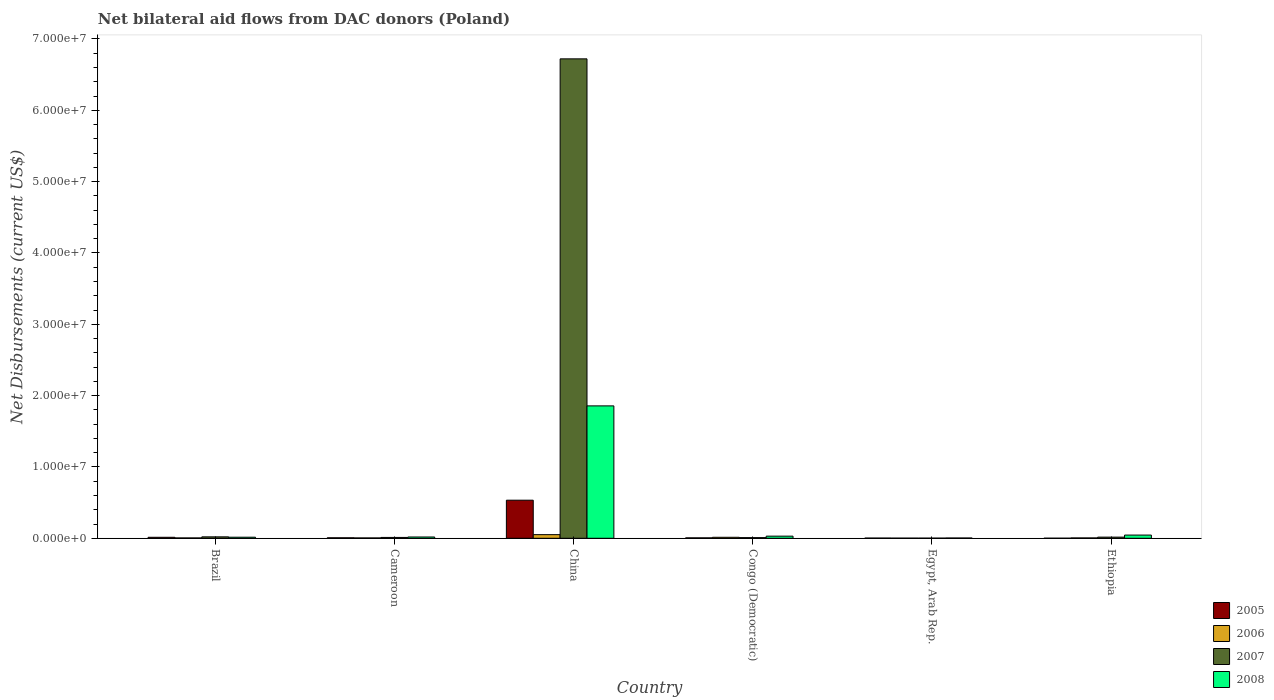Are the number of bars on each tick of the X-axis equal?
Make the answer very short. Yes. How many bars are there on the 6th tick from the left?
Your answer should be very brief. 4. What is the label of the 6th group of bars from the left?
Keep it short and to the point. Ethiopia. In how many cases, is the number of bars for a given country not equal to the number of legend labels?
Make the answer very short. 0. What is the net bilateral aid flows in 2008 in Egypt, Arab Rep.?
Ensure brevity in your answer.  4.00e+04. Across all countries, what is the maximum net bilateral aid flows in 2005?
Make the answer very short. 5.34e+06. In which country was the net bilateral aid flows in 2008 minimum?
Ensure brevity in your answer.  Egypt, Arab Rep. What is the total net bilateral aid flows in 2005 in the graph?
Offer a terse response. 5.65e+06. What is the difference between the net bilateral aid flows in 2005 in Cameroon and that in Ethiopia?
Give a very brief answer. 6.00e+04. What is the average net bilateral aid flows in 2007 per country?
Ensure brevity in your answer.  1.13e+07. What is the difference between the net bilateral aid flows of/in 2008 and net bilateral aid flows of/in 2005 in Cameroon?
Give a very brief answer. 1.10e+05. In how many countries, is the net bilateral aid flows in 2008 greater than 32000000 US$?
Make the answer very short. 0. What is the ratio of the net bilateral aid flows in 2008 in Cameroon to that in China?
Keep it short and to the point. 0.01. Is the net bilateral aid flows in 2008 in Cameroon less than that in Congo (Democratic)?
Keep it short and to the point. Yes. What is the difference between the highest and the second highest net bilateral aid flows in 2008?
Keep it short and to the point. 1.83e+07. What is the difference between the highest and the lowest net bilateral aid flows in 2008?
Your response must be concise. 1.85e+07. In how many countries, is the net bilateral aid flows in 2005 greater than the average net bilateral aid flows in 2005 taken over all countries?
Your answer should be very brief. 1. Is it the case that in every country, the sum of the net bilateral aid flows in 2007 and net bilateral aid flows in 2006 is greater than the sum of net bilateral aid flows in 2008 and net bilateral aid flows in 2005?
Keep it short and to the point. No. Is it the case that in every country, the sum of the net bilateral aid flows in 2007 and net bilateral aid flows in 2008 is greater than the net bilateral aid flows in 2005?
Make the answer very short. Yes. How many bars are there?
Keep it short and to the point. 24. Are all the bars in the graph horizontal?
Your answer should be very brief. No. How many countries are there in the graph?
Provide a succinct answer. 6. What is the difference between two consecutive major ticks on the Y-axis?
Make the answer very short. 1.00e+07. Are the values on the major ticks of Y-axis written in scientific E-notation?
Your response must be concise. Yes. Does the graph contain grids?
Make the answer very short. No. Where does the legend appear in the graph?
Ensure brevity in your answer.  Bottom right. How are the legend labels stacked?
Offer a very short reply. Vertical. What is the title of the graph?
Make the answer very short. Net bilateral aid flows from DAC donors (Poland). Does "1967" appear as one of the legend labels in the graph?
Provide a short and direct response. No. What is the label or title of the Y-axis?
Keep it short and to the point. Net Disbursements (current US$). What is the Net Disbursements (current US$) in 2006 in Brazil?
Offer a terse response. 5.00e+04. What is the Net Disbursements (current US$) in 2007 in Brazil?
Offer a very short reply. 2.00e+05. What is the Net Disbursements (current US$) in 2005 in Cameroon?
Your answer should be compact. 7.00e+04. What is the Net Disbursements (current US$) in 2008 in Cameroon?
Provide a succinct answer. 1.80e+05. What is the Net Disbursements (current US$) in 2005 in China?
Ensure brevity in your answer.  5.34e+06. What is the Net Disbursements (current US$) in 2006 in China?
Keep it short and to the point. 5.10e+05. What is the Net Disbursements (current US$) in 2007 in China?
Keep it short and to the point. 6.72e+07. What is the Net Disbursements (current US$) of 2008 in China?
Provide a short and direct response. 1.86e+07. What is the Net Disbursements (current US$) of 2005 in Congo (Democratic)?
Ensure brevity in your answer.  6.00e+04. What is the Net Disbursements (current US$) in 2006 in Congo (Democratic)?
Your answer should be compact. 1.40e+05. What is the Net Disbursements (current US$) in 2007 in Congo (Democratic)?
Offer a very short reply. 9.00e+04. What is the Net Disbursements (current US$) in 2005 in Egypt, Arab Rep.?
Offer a very short reply. 3.00e+04. What is the Net Disbursements (current US$) of 2006 in Egypt, Arab Rep.?
Ensure brevity in your answer.  2.00e+04. What is the Net Disbursements (current US$) in 2008 in Egypt, Arab Rep.?
Provide a succinct answer. 4.00e+04. What is the Net Disbursements (current US$) of 2005 in Ethiopia?
Your answer should be compact. 10000. What is the Net Disbursements (current US$) of 2007 in Ethiopia?
Ensure brevity in your answer.  1.60e+05. Across all countries, what is the maximum Net Disbursements (current US$) in 2005?
Offer a very short reply. 5.34e+06. Across all countries, what is the maximum Net Disbursements (current US$) in 2006?
Provide a succinct answer. 5.10e+05. Across all countries, what is the maximum Net Disbursements (current US$) in 2007?
Keep it short and to the point. 6.72e+07. Across all countries, what is the maximum Net Disbursements (current US$) of 2008?
Provide a succinct answer. 1.86e+07. Across all countries, what is the minimum Net Disbursements (current US$) of 2005?
Offer a terse response. 10000. Across all countries, what is the minimum Net Disbursements (current US$) of 2006?
Make the answer very short. 2.00e+04. Across all countries, what is the minimum Net Disbursements (current US$) in 2007?
Your response must be concise. 2.00e+04. What is the total Net Disbursements (current US$) of 2005 in the graph?
Make the answer very short. 5.65e+06. What is the total Net Disbursements (current US$) in 2006 in the graph?
Make the answer very short. 8.20e+05. What is the total Net Disbursements (current US$) in 2007 in the graph?
Provide a succinct answer. 6.78e+07. What is the total Net Disbursements (current US$) of 2008 in the graph?
Make the answer very short. 1.97e+07. What is the difference between the Net Disbursements (current US$) of 2005 in Brazil and that in Cameroon?
Your answer should be compact. 7.00e+04. What is the difference between the Net Disbursements (current US$) of 2005 in Brazil and that in China?
Make the answer very short. -5.20e+06. What is the difference between the Net Disbursements (current US$) of 2006 in Brazil and that in China?
Keep it short and to the point. -4.60e+05. What is the difference between the Net Disbursements (current US$) in 2007 in Brazil and that in China?
Give a very brief answer. -6.70e+07. What is the difference between the Net Disbursements (current US$) of 2008 in Brazil and that in China?
Give a very brief answer. -1.84e+07. What is the difference between the Net Disbursements (current US$) of 2006 in Brazil and that in Congo (Democratic)?
Offer a very short reply. -9.00e+04. What is the difference between the Net Disbursements (current US$) in 2005 in Brazil and that in Egypt, Arab Rep.?
Offer a terse response. 1.10e+05. What is the difference between the Net Disbursements (current US$) in 2008 in Brazil and that in Egypt, Arab Rep.?
Keep it short and to the point. 1.10e+05. What is the difference between the Net Disbursements (current US$) in 2005 in Brazil and that in Ethiopia?
Offer a terse response. 1.30e+05. What is the difference between the Net Disbursements (current US$) in 2006 in Brazil and that in Ethiopia?
Your response must be concise. 0. What is the difference between the Net Disbursements (current US$) of 2007 in Brazil and that in Ethiopia?
Offer a terse response. 4.00e+04. What is the difference between the Net Disbursements (current US$) in 2005 in Cameroon and that in China?
Give a very brief answer. -5.27e+06. What is the difference between the Net Disbursements (current US$) of 2006 in Cameroon and that in China?
Your response must be concise. -4.60e+05. What is the difference between the Net Disbursements (current US$) of 2007 in Cameroon and that in China?
Offer a very short reply. -6.71e+07. What is the difference between the Net Disbursements (current US$) of 2008 in Cameroon and that in China?
Keep it short and to the point. -1.84e+07. What is the difference between the Net Disbursements (current US$) of 2006 in Cameroon and that in Egypt, Arab Rep.?
Your answer should be very brief. 3.00e+04. What is the difference between the Net Disbursements (current US$) of 2006 in Cameroon and that in Ethiopia?
Your answer should be very brief. 0. What is the difference between the Net Disbursements (current US$) in 2005 in China and that in Congo (Democratic)?
Make the answer very short. 5.28e+06. What is the difference between the Net Disbursements (current US$) in 2006 in China and that in Congo (Democratic)?
Offer a very short reply. 3.70e+05. What is the difference between the Net Disbursements (current US$) of 2007 in China and that in Congo (Democratic)?
Offer a very short reply. 6.71e+07. What is the difference between the Net Disbursements (current US$) in 2008 in China and that in Congo (Democratic)?
Offer a very short reply. 1.83e+07. What is the difference between the Net Disbursements (current US$) of 2005 in China and that in Egypt, Arab Rep.?
Your answer should be compact. 5.31e+06. What is the difference between the Net Disbursements (current US$) of 2007 in China and that in Egypt, Arab Rep.?
Provide a short and direct response. 6.72e+07. What is the difference between the Net Disbursements (current US$) in 2008 in China and that in Egypt, Arab Rep.?
Your answer should be very brief. 1.85e+07. What is the difference between the Net Disbursements (current US$) of 2005 in China and that in Ethiopia?
Offer a very short reply. 5.33e+06. What is the difference between the Net Disbursements (current US$) of 2006 in China and that in Ethiopia?
Provide a succinct answer. 4.60e+05. What is the difference between the Net Disbursements (current US$) in 2007 in China and that in Ethiopia?
Offer a very short reply. 6.70e+07. What is the difference between the Net Disbursements (current US$) of 2008 in China and that in Ethiopia?
Keep it short and to the point. 1.81e+07. What is the difference between the Net Disbursements (current US$) of 2007 in Congo (Democratic) and that in Egypt, Arab Rep.?
Offer a terse response. 7.00e+04. What is the difference between the Net Disbursements (current US$) in 2005 in Congo (Democratic) and that in Ethiopia?
Keep it short and to the point. 5.00e+04. What is the difference between the Net Disbursements (current US$) in 2006 in Congo (Democratic) and that in Ethiopia?
Make the answer very short. 9.00e+04. What is the difference between the Net Disbursements (current US$) of 2007 in Egypt, Arab Rep. and that in Ethiopia?
Make the answer very short. -1.40e+05. What is the difference between the Net Disbursements (current US$) in 2008 in Egypt, Arab Rep. and that in Ethiopia?
Keep it short and to the point. -4.10e+05. What is the difference between the Net Disbursements (current US$) of 2005 in Brazil and the Net Disbursements (current US$) of 2006 in Cameroon?
Provide a short and direct response. 9.00e+04. What is the difference between the Net Disbursements (current US$) of 2005 in Brazil and the Net Disbursements (current US$) of 2007 in Cameroon?
Provide a short and direct response. 2.00e+04. What is the difference between the Net Disbursements (current US$) of 2005 in Brazil and the Net Disbursements (current US$) of 2008 in Cameroon?
Provide a succinct answer. -4.00e+04. What is the difference between the Net Disbursements (current US$) of 2005 in Brazil and the Net Disbursements (current US$) of 2006 in China?
Provide a short and direct response. -3.70e+05. What is the difference between the Net Disbursements (current US$) in 2005 in Brazil and the Net Disbursements (current US$) in 2007 in China?
Keep it short and to the point. -6.71e+07. What is the difference between the Net Disbursements (current US$) in 2005 in Brazil and the Net Disbursements (current US$) in 2008 in China?
Provide a short and direct response. -1.84e+07. What is the difference between the Net Disbursements (current US$) in 2006 in Brazil and the Net Disbursements (current US$) in 2007 in China?
Provide a succinct answer. -6.72e+07. What is the difference between the Net Disbursements (current US$) in 2006 in Brazil and the Net Disbursements (current US$) in 2008 in China?
Your answer should be very brief. -1.85e+07. What is the difference between the Net Disbursements (current US$) of 2007 in Brazil and the Net Disbursements (current US$) of 2008 in China?
Your answer should be compact. -1.84e+07. What is the difference between the Net Disbursements (current US$) in 2005 in Brazil and the Net Disbursements (current US$) in 2008 in Congo (Democratic)?
Give a very brief answer. -1.60e+05. What is the difference between the Net Disbursements (current US$) of 2006 in Brazil and the Net Disbursements (current US$) of 2007 in Congo (Democratic)?
Your answer should be compact. -4.00e+04. What is the difference between the Net Disbursements (current US$) of 2006 in Brazil and the Net Disbursements (current US$) of 2008 in Congo (Democratic)?
Provide a short and direct response. -2.50e+05. What is the difference between the Net Disbursements (current US$) in 2006 in Brazil and the Net Disbursements (current US$) in 2008 in Egypt, Arab Rep.?
Provide a succinct answer. 10000. What is the difference between the Net Disbursements (current US$) in 2007 in Brazil and the Net Disbursements (current US$) in 2008 in Egypt, Arab Rep.?
Make the answer very short. 1.60e+05. What is the difference between the Net Disbursements (current US$) in 2005 in Brazil and the Net Disbursements (current US$) in 2008 in Ethiopia?
Make the answer very short. -3.10e+05. What is the difference between the Net Disbursements (current US$) of 2006 in Brazil and the Net Disbursements (current US$) of 2007 in Ethiopia?
Offer a terse response. -1.10e+05. What is the difference between the Net Disbursements (current US$) in 2006 in Brazil and the Net Disbursements (current US$) in 2008 in Ethiopia?
Give a very brief answer. -4.00e+05. What is the difference between the Net Disbursements (current US$) of 2007 in Brazil and the Net Disbursements (current US$) of 2008 in Ethiopia?
Keep it short and to the point. -2.50e+05. What is the difference between the Net Disbursements (current US$) of 2005 in Cameroon and the Net Disbursements (current US$) of 2006 in China?
Keep it short and to the point. -4.40e+05. What is the difference between the Net Disbursements (current US$) of 2005 in Cameroon and the Net Disbursements (current US$) of 2007 in China?
Ensure brevity in your answer.  -6.71e+07. What is the difference between the Net Disbursements (current US$) in 2005 in Cameroon and the Net Disbursements (current US$) in 2008 in China?
Give a very brief answer. -1.85e+07. What is the difference between the Net Disbursements (current US$) of 2006 in Cameroon and the Net Disbursements (current US$) of 2007 in China?
Make the answer very short. -6.72e+07. What is the difference between the Net Disbursements (current US$) of 2006 in Cameroon and the Net Disbursements (current US$) of 2008 in China?
Offer a very short reply. -1.85e+07. What is the difference between the Net Disbursements (current US$) in 2007 in Cameroon and the Net Disbursements (current US$) in 2008 in China?
Provide a short and direct response. -1.84e+07. What is the difference between the Net Disbursements (current US$) in 2005 in Cameroon and the Net Disbursements (current US$) in 2006 in Congo (Democratic)?
Your answer should be very brief. -7.00e+04. What is the difference between the Net Disbursements (current US$) in 2006 in Cameroon and the Net Disbursements (current US$) in 2007 in Congo (Democratic)?
Make the answer very short. -4.00e+04. What is the difference between the Net Disbursements (current US$) in 2006 in Cameroon and the Net Disbursements (current US$) in 2008 in Congo (Democratic)?
Provide a succinct answer. -2.50e+05. What is the difference between the Net Disbursements (current US$) in 2005 in Cameroon and the Net Disbursements (current US$) in 2007 in Egypt, Arab Rep.?
Your answer should be very brief. 5.00e+04. What is the difference between the Net Disbursements (current US$) of 2005 in Cameroon and the Net Disbursements (current US$) of 2008 in Egypt, Arab Rep.?
Your answer should be very brief. 3.00e+04. What is the difference between the Net Disbursements (current US$) of 2006 in Cameroon and the Net Disbursements (current US$) of 2008 in Egypt, Arab Rep.?
Your answer should be compact. 10000. What is the difference between the Net Disbursements (current US$) in 2005 in Cameroon and the Net Disbursements (current US$) in 2006 in Ethiopia?
Your answer should be very brief. 2.00e+04. What is the difference between the Net Disbursements (current US$) of 2005 in Cameroon and the Net Disbursements (current US$) of 2008 in Ethiopia?
Ensure brevity in your answer.  -3.80e+05. What is the difference between the Net Disbursements (current US$) of 2006 in Cameroon and the Net Disbursements (current US$) of 2007 in Ethiopia?
Your answer should be compact. -1.10e+05. What is the difference between the Net Disbursements (current US$) in 2006 in Cameroon and the Net Disbursements (current US$) in 2008 in Ethiopia?
Keep it short and to the point. -4.00e+05. What is the difference between the Net Disbursements (current US$) of 2007 in Cameroon and the Net Disbursements (current US$) of 2008 in Ethiopia?
Ensure brevity in your answer.  -3.30e+05. What is the difference between the Net Disbursements (current US$) in 2005 in China and the Net Disbursements (current US$) in 2006 in Congo (Democratic)?
Provide a short and direct response. 5.20e+06. What is the difference between the Net Disbursements (current US$) of 2005 in China and the Net Disbursements (current US$) of 2007 in Congo (Democratic)?
Make the answer very short. 5.25e+06. What is the difference between the Net Disbursements (current US$) of 2005 in China and the Net Disbursements (current US$) of 2008 in Congo (Democratic)?
Your response must be concise. 5.04e+06. What is the difference between the Net Disbursements (current US$) of 2006 in China and the Net Disbursements (current US$) of 2007 in Congo (Democratic)?
Ensure brevity in your answer.  4.20e+05. What is the difference between the Net Disbursements (current US$) in 2007 in China and the Net Disbursements (current US$) in 2008 in Congo (Democratic)?
Give a very brief answer. 6.69e+07. What is the difference between the Net Disbursements (current US$) of 2005 in China and the Net Disbursements (current US$) of 2006 in Egypt, Arab Rep.?
Offer a terse response. 5.32e+06. What is the difference between the Net Disbursements (current US$) in 2005 in China and the Net Disbursements (current US$) in 2007 in Egypt, Arab Rep.?
Make the answer very short. 5.32e+06. What is the difference between the Net Disbursements (current US$) in 2005 in China and the Net Disbursements (current US$) in 2008 in Egypt, Arab Rep.?
Your answer should be very brief. 5.30e+06. What is the difference between the Net Disbursements (current US$) of 2006 in China and the Net Disbursements (current US$) of 2007 in Egypt, Arab Rep.?
Make the answer very short. 4.90e+05. What is the difference between the Net Disbursements (current US$) of 2006 in China and the Net Disbursements (current US$) of 2008 in Egypt, Arab Rep.?
Provide a short and direct response. 4.70e+05. What is the difference between the Net Disbursements (current US$) of 2007 in China and the Net Disbursements (current US$) of 2008 in Egypt, Arab Rep.?
Your answer should be compact. 6.72e+07. What is the difference between the Net Disbursements (current US$) in 2005 in China and the Net Disbursements (current US$) in 2006 in Ethiopia?
Provide a short and direct response. 5.29e+06. What is the difference between the Net Disbursements (current US$) in 2005 in China and the Net Disbursements (current US$) in 2007 in Ethiopia?
Your answer should be very brief. 5.18e+06. What is the difference between the Net Disbursements (current US$) of 2005 in China and the Net Disbursements (current US$) of 2008 in Ethiopia?
Provide a short and direct response. 4.89e+06. What is the difference between the Net Disbursements (current US$) in 2006 in China and the Net Disbursements (current US$) in 2008 in Ethiopia?
Make the answer very short. 6.00e+04. What is the difference between the Net Disbursements (current US$) of 2007 in China and the Net Disbursements (current US$) of 2008 in Ethiopia?
Give a very brief answer. 6.68e+07. What is the difference between the Net Disbursements (current US$) in 2005 in Congo (Democratic) and the Net Disbursements (current US$) in 2008 in Egypt, Arab Rep.?
Keep it short and to the point. 2.00e+04. What is the difference between the Net Disbursements (current US$) in 2006 in Congo (Democratic) and the Net Disbursements (current US$) in 2007 in Egypt, Arab Rep.?
Your response must be concise. 1.20e+05. What is the difference between the Net Disbursements (current US$) in 2006 in Congo (Democratic) and the Net Disbursements (current US$) in 2008 in Egypt, Arab Rep.?
Give a very brief answer. 1.00e+05. What is the difference between the Net Disbursements (current US$) of 2005 in Congo (Democratic) and the Net Disbursements (current US$) of 2006 in Ethiopia?
Your response must be concise. 10000. What is the difference between the Net Disbursements (current US$) in 2005 in Congo (Democratic) and the Net Disbursements (current US$) in 2008 in Ethiopia?
Offer a very short reply. -3.90e+05. What is the difference between the Net Disbursements (current US$) in 2006 in Congo (Democratic) and the Net Disbursements (current US$) in 2008 in Ethiopia?
Make the answer very short. -3.10e+05. What is the difference between the Net Disbursements (current US$) of 2007 in Congo (Democratic) and the Net Disbursements (current US$) of 2008 in Ethiopia?
Provide a short and direct response. -3.60e+05. What is the difference between the Net Disbursements (current US$) in 2005 in Egypt, Arab Rep. and the Net Disbursements (current US$) in 2007 in Ethiopia?
Your answer should be very brief. -1.30e+05. What is the difference between the Net Disbursements (current US$) in 2005 in Egypt, Arab Rep. and the Net Disbursements (current US$) in 2008 in Ethiopia?
Provide a short and direct response. -4.20e+05. What is the difference between the Net Disbursements (current US$) in 2006 in Egypt, Arab Rep. and the Net Disbursements (current US$) in 2007 in Ethiopia?
Give a very brief answer. -1.40e+05. What is the difference between the Net Disbursements (current US$) in 2006 in Egypt, Arab Rep. and the Net Disbursements (current US$) in 2008 in Ethiopia?
Give a very brief answer. -4.30e+05. What is the difference between the Net Disbursements (current US$) of 2007 in Egypt, Arab Rep. and the Net Disbursements (current US$) of 2008 in Ethiopia?
Provide a short and direct response. -4.30e+05. What is the average Net Disbursements (current US$) of 2005 per country?
Your answer should be very brief. 9.42e+05. What is the average Net Disbursements (current US$) in 2006 per country?
Make the answer very short. 1.37e+05. What is the average Net Disbursements (current US$) of 2007 per country?
Provide a short and direct response. 1.13e+07. What is the average Net Disbursements (current US$) in 2008 per country?
Your answer should be very brief. 3.28e+06. What is the difference between the Net Disbursements (current US$) of 2005 and Net Disbursements (current US$) of 2008 in Brazil?
Offer a terse response. -10000. What is the difference between the Net Disbursements (current US$) in 2006 and Net Disbursements (current US$) in 2008 in Brazil?
Offer a very short reply. -1.00e+05. What is the difference between the Net Disbursements (current US$) of 2007 and Net Disbursements (current US$) of 2008 in Brazil?
Give a very brief answer. 5.00e+04. What is the difference between the Net Disbursements (current US$) in 2005 and Net Disbursements (current US$) in 2006 in Cameroon?
Offer a terse response. 2.00e+04. What is the difference between the Net Disbursements (current US$) of 2005 and Net Disbursements (current US$) of 2007 in Cameroon?
Keep it short and to the point. -5.00e+04. What is the difference between the Net Disbursements (current US$) in 2006 and Net Disbursements (current US$) in 2007 in Cameroon?
Keep it short and to the point. -7.00e+04. What is the difference between the Net Disbursements (current US$) in 2006 and Net Disbursements (current US$) in 2008 in Cameroon?
Provide a short and direct response. -1.30e+05. What is the difference between the Net Disbursements (current US$) of 2007 and Net Disbursements (current US$) of 2008 in Cameroon?
Your answer should be compact. -6.00e+04. What is the difference between the Net Disbursements (current US$) of 2005 and Net Disbursements (current US$) of 2006 in China?
Offer a terse response. 4.83e+06. What is the difference between the Net Disbursements (current US$) of 2005 and Net Disbursements (current US$) of 2007 in China?
Ensure brevity in your answer.  -6.19e+07. What is the difference between the Net Disbursements (current US$) in 2005 and Net Disbursements (current US$) in 2008 in China?
Provide a short and direct response. -1.32e+07. What is the difference between the Net Disbursements (current US$) in 2006 and Net Disbursements (current US$) in 2007 in China?
Your answer should be compact. -6.67e+07. What is the difference between the Net Disbursements (current US$) in 2006 and Net Disbursements (current US$) in 2008 in China?
Your answer should be very brief. -1.80e+07. What is the difference between the Net Disbursements (current US$) in 2007 and Net Disbursements (current US$) in 2008 in China?
Make the answer very short. 4.86e+07. What is the difference between the Net Disbursements (current US$) in 2005 and Net Disbursements (current US$) in 2006 in Congo (Democratic)?
Your answer should be compact. -8.00e+04. What is the difference between the Net Disbursements (current US$) of 2005 and Net Disbursements (current US$) of 2007 in Congo (Democratic)?
Provide a short and direct response. -3.00e+04. What is the difference between the Net Disbursements (current US$) in 2005 and Net Disbursements (current US$) in 2008 in Congo (Democratic)?
Provide a short and direct response. -2.40e+05. What is the difference between the Net Disbursements (current US$) of 2006 and Net Disbursements (current US$) of 2008 in Congo (Democratic)?
Make the answer very short. -1.60e+05. What is the difference between the Net Disbursements (current US$) in 2005 and Net Disbursements (current US$) in 2006 in Egypt, Arab Rep.?
Your answer should be compact. 10000. What is the difference between the Net Disbursements (current US$) of 2005 and Net Disbursements (current US$) of 2007 in Egypt, Arab Rep.?
Make the answer very short. 10000. What is the difference between the Net Disbursements (current US$) in 2005 and Net Disbursements (current US$) in 2006 in Ethiopia?
Provide a succinct answer. -4.00e+04. What is the difference between the Net Disbursements (current US$) in 2005 and Net Disbursements (current US$) in 2008 in Ethiopia?
Provide a succinct answer. -4.40e+05. What is the difference between the Net Disbursements (current US$) of 2006 and Net Disbursements (current US$) of 2008 in Ethiopia?
Offer a terse response. -4.00e+05. What is the ratio of the Net Disbursements (current US$) in 2005 in Brazil to that in Cameroon?
Give a very brief answer. 2. What is the ratio of the Net Disbursements (current US$) of 2006 in Brazil to that in Cameroon?
Provide a succinct answer. 1. What is the ratio of the Net Disbursements (current US$) of 2008 in Brazil to that in Cameroon?
Ensure brevity in your answer.  0.83. What is the ratio of the Net Disbursements (current US$) in 2005 in Brazil to that in China?
Your response must be concise. 0.03. What is the ratio of the Net Disbursements (current US$) of 2006 in Brazil to that in China?
Offer a terse response. 0.1. What is the ratio of the Net Disbursements (current US$) in 2007 in Brazil to that in China?
Provide a short and direct response. 0. What is the ratio of the Net Disbursements (current US$) of 2008 in Brazil to that in China?
Keep it short and to the point. 0.01. What is the ratio of the Net Disbursements (current US$) in 2005 in Brazil to that in Congo (Democratic)?
Ensure brevity in your answer.  2.33. What is the ratio of the Net Disbursements (current US$) of 2006 in Brazil to that in Congo (Democratic)?
Provide a short and direct response. 0.36. What is the ratio of the Net Disbursements (current US$) of 2007 in Brazil to that in Congo (Democratic)?
Give a very brief answer. 2.22. What is the ratio of the Net Disbursements (current US$) in 2005 in Brazil to that in Egypt, Arab Rep.?
Offer a terse response. 4.67. What is the ratio of the Net Disbursements (current US$) of 2006 in Brazil to that in Egypt, Arab Rep.?
Make the answer very short. 2.5. What is the ratio of the Net Disbursements (current US$) in 2007 in Brazil to that in Egypt, Arab Rep.?
Offer a terse response. 10. What is the ratio of the Net Disbursements (current US$) of 2008 in Brazil to that in Egypt, Arab Rep.?
Keep it short and to the point. 3.75. What is the ratio of the Net Disbursements (current US$) of 2007 in Brazil to that in Ethiopia?
Offer a terse response. 1.25. What is the ratio of the Net Disbursements (current US$) in 2005 in Cameroon to that in China?
Your answer should be compact. 0.01. What is the ratio of the Net Disbursements (current US$) of 2006 in Cameroon to that in China?
Offer a very short reply. 0.1. What is the ratio of the Net Disbursements (current US$) in 2007 in Cameroon to that in China?
Your response must be concise. 0. What is the ratio of the Net Disbursements (current US$) in 2008 in Cameroon to that in China?
Your answer should be compact. 0.01. What is the ratio of the Net Disbursements (current US$) in 2005 in Cameroon to that in Congo (Democratic)?
Provide a short and direct response. 1.17. What is the ratio of the Net Disbursements (current US$) in 2006 in Cameroon to that in Congo (Democratic)?
Offer a terse response. 0.36. What is the ratio of the Net Disbursements (current US$) in 2008 in Cameroon to that in Congo (Democratic)?
Offer a very short reply. 0.6. What is the ratio of the Net Disbursements (current US$) of 2005 in Cameroon to that in Egypt, Arab Rep.?
Provide a succinct answer. 2.33. What is the ratio of the Net Disbursements (current US$) in 2007 in Cameroon to that in Egypt, Arab Rep.?
Make the answer very short. 6. What is the ratio of the Net Disbursements (current US$) in 2005 in China to that in Congo (Democratic)?
Give a very brief answer. 89. What is the ratio of the Net Disbursements (current US$) in 2006 in China to that in Congo (Democratic)?
Provide a succinct answer. 3.64. What is the ratio of the Net Disbursements (current US$) in 2007 in China to that in Congo (Democratic)?
Your response must be concise. 746.78. What is the ratio of the Net Disbursements (current US$) of 2008 in China to that in Congo (Democratic)?
Provide a succinct answer. 61.87. What is the ratio of the Net Disbursements (current US$) in 2005 in China to that in Egypt, Arab Rep.?
Provide a short and direct response. 178. What is the ratio of the Net Disbursements (current US$) of 2006 in China to that in Egypt, Arab Rep.?
Keep it short and to the point. 25.5. What is the ratio of the Net Disbursements (current US$) of 2007 in China to that in Egypt, Arab Rep.?
Your answer should be very brief. 3360.5. What is the ratio of the Net Disbursements (current US$) in 2008 in China to that in Egypt, Arab Rep.?
Keep it short and to the point. 464. What is the ratio of the Net Disbursements (current US$) in 2005 in China to that in Ethiopia?
Ensure brevity in your answer.  534. What is the ratio of the Net Disbursements (current US$) of 2007 in China to that in Ethiopia?
Give a very brief answer. 420.06. What is the ratio of the Net Disbursements (current US$) of 2008 in China to that in Ethiopia?
Provide a short and direct response. 41.24. What is the ratio of the Net Disbursements (current US$) of 2005 in Congo (Democratic) to that in Egypt, Arab Rep.?
Make the answer very short. 2. What is the ratio of the Net Disbursements (current US$) of 2008 in Congo (Democratic) to that in Egypt, Arab Rep.?
Your answer should be very brief. 7.5. What is the ratio of the Net Disbursements (current US$) of 2005 in Congo (Democratic) to that in Ethiopia?
Offer a very short reply. 6. What is the ratio of the Net Disbursements (current US$) of 2007 in Congo (Democratic) to that in Ethiopia?
Provide a short and direct response. 0.56. What is the ratio of the Net Disbursements (current US$) of 2008 in Congo (Democratic) to that in Ethiopia?
Your answer should be very brief. 0.67. What is the ratio of the Net Disbursements (current US$) of 2006 in Egypt, Arab Rep. to that in Ethiopia?
Make the answer very short. 0.4. What is the ratio of the Net Disbursements (current US$) of 2007 in Egypt, Arab Rep. to that in Ethiopia?
Your answer should be compact. 0.12. What is the ratio of the Net Disbursements (current US$) in 2008 in Egypt, Arab Rep. to that in Ethiopia?
Keep it short and to the point. 0.09. What is the difference between the highest and the second highest Net Disbursements (current US$) in 2005?
Your answer should be very brief. 5.20e+06. What is the difference between the highest and the second highest Net Disbursements (current US$) in 2007?
Keep it short and to the point. 6.70e+07. What is the difference between the highest and the second highest Net Disbursements (current US$) of 2008?
Provide a short and direct response. 1.81e+07. What is the difference between the highest and the lowest Net Disbursements (current US$) of 2005?
Offer a very short reply. 5.33e+06. What is the difference between the highest and the lowest Net Disbursements (current US$) of 2006?
Provide a short and direct response. 4.90e+05. What is the difference between the highest and the lowest Net Disbursements (current US$) in 2007?
Your answer should be compact. 6.72e+07. What is the difference between the highest and the lowest Net Disbursements (current US$) in 2008?
Your answer should be compact. 1.85e+07. 